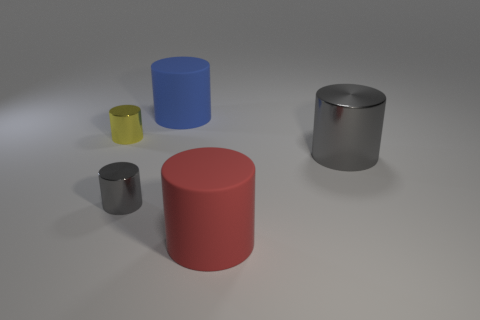What is the cylinder that is both in front of the large gray cylinder and right of the blue cylinder made of?
Provide a short and direct response. Rubber. Are there more red rubber cylinders in front of the large gray thing than cyan matte balls?
Make the answer very short. Yes. What is the material of the large gray cylinder?
Your answer should be compact. Metal. What number of yellow matte cubes have the same size as the yellow object?
Give a very brief answer. 0. Is the number of big objects behind the large gray metallic cylinder the same as the number of small yellow metal objects in front of the red cylinder?
Make the answer very short. No. Do the small yellow cylinder and the small gray thing have the same material?
Your answer should be very brief. Yes. There is a gray cylinder that is on the left side of the large metal cylinder; are there any blue rubber things that are to the right of it?
Provide a succinct answer. Yes. Are there any red rubber things that have the same shape as the big gray object?
Your answer should be compact. Yes. The big thing to the left of the big rubber object on the right side of the blue object is made of what material?
Offer a terse response. Rubber. What is the size of the red cylinder?
Your response must be concise. Large. 